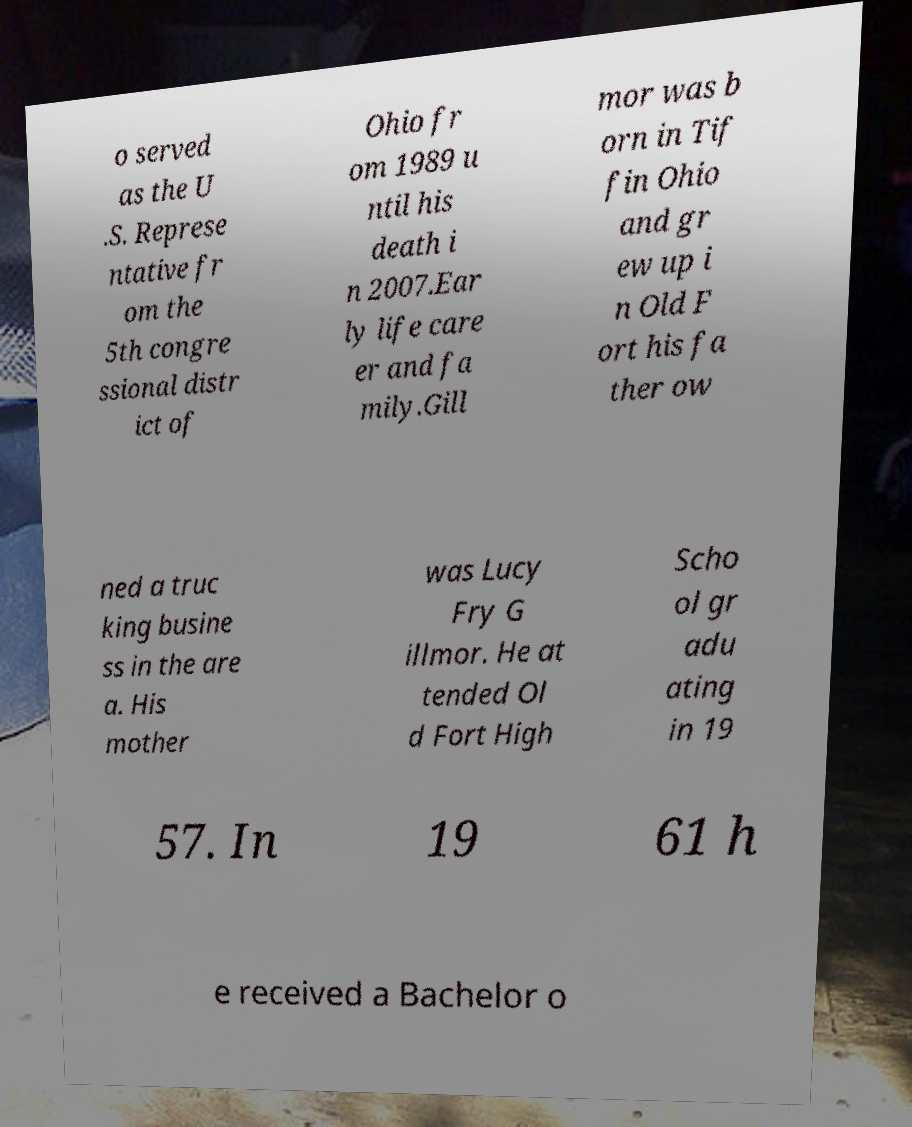Can you read and provide the text displayed in the image?This photo seems to have some interesting text. Can you extract and type it out for me? o served as the U .S. Represe ntative fr om the 5th congre ssional distr ict of Ohio fr om 1989 u ntil his death i n 2007.Ear ly life care er and fa mily.Gill mor was b orn in Tif fin Ohio and gr ew up i n Old F ort his fa ther ow ned a truc king busine ss in the are a. His mother was Lucy Fry G illmor. He at tended Ol d Fort High Scho ol gr adu ating in 19 57. In 19 61 h e received a Bachelor o 